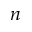<formula> <loc_0><loc_0><loc_500><loc_500>n</formula> 